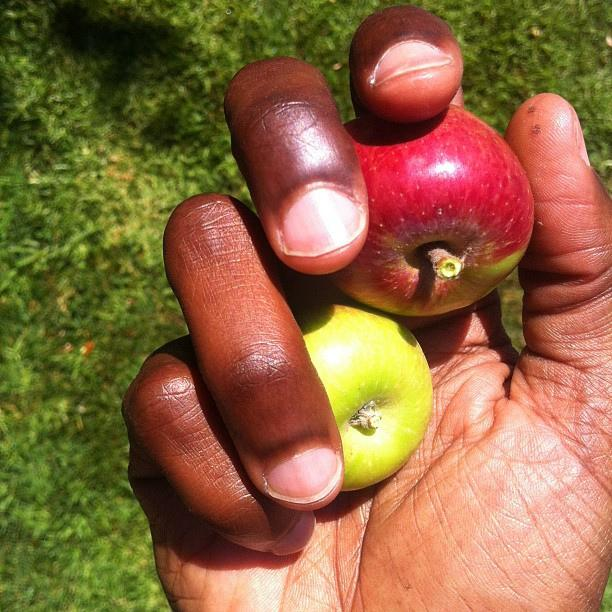What race is this person holding the apples? black 